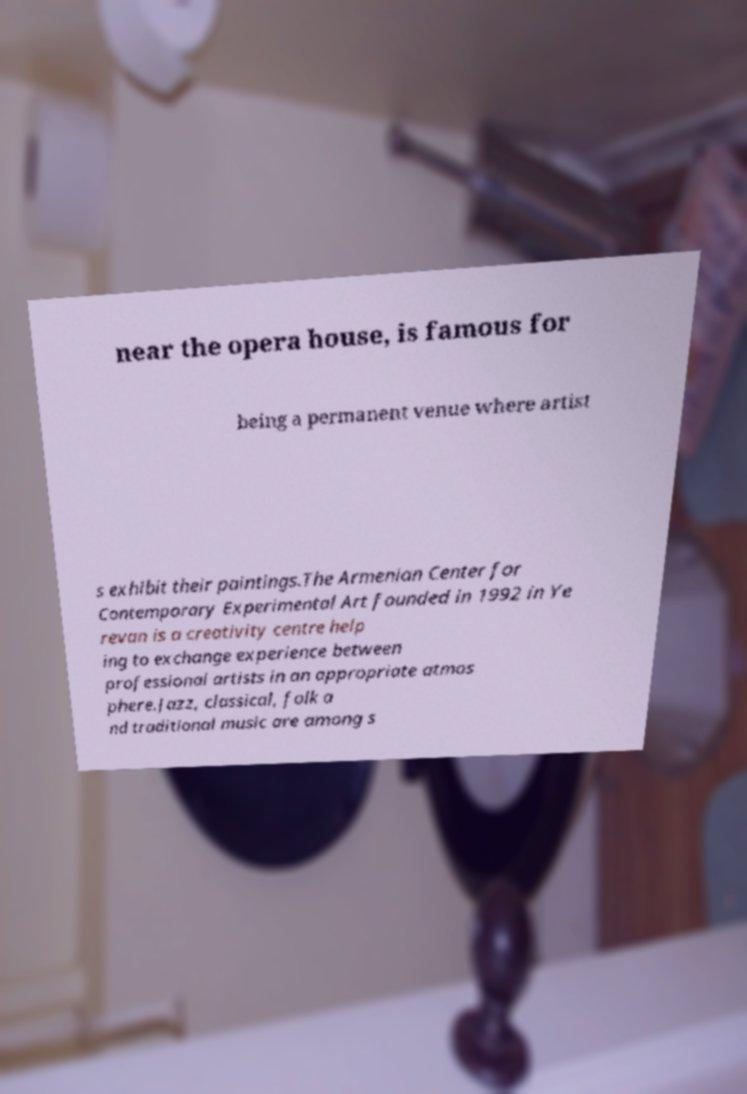I need the written content from this picture converted into text. Can you do that? near the opera house, is famous for being a permanent venue where artist s exhibit their paintings.The Armenian Center for Contemporary Experimental Art founded in 1992 in Ye revan is a creativity centre help ing to exchange experience between professional artists in an appropriate atmos phere.Jazz, classical, folk a nd traditional music are among s 